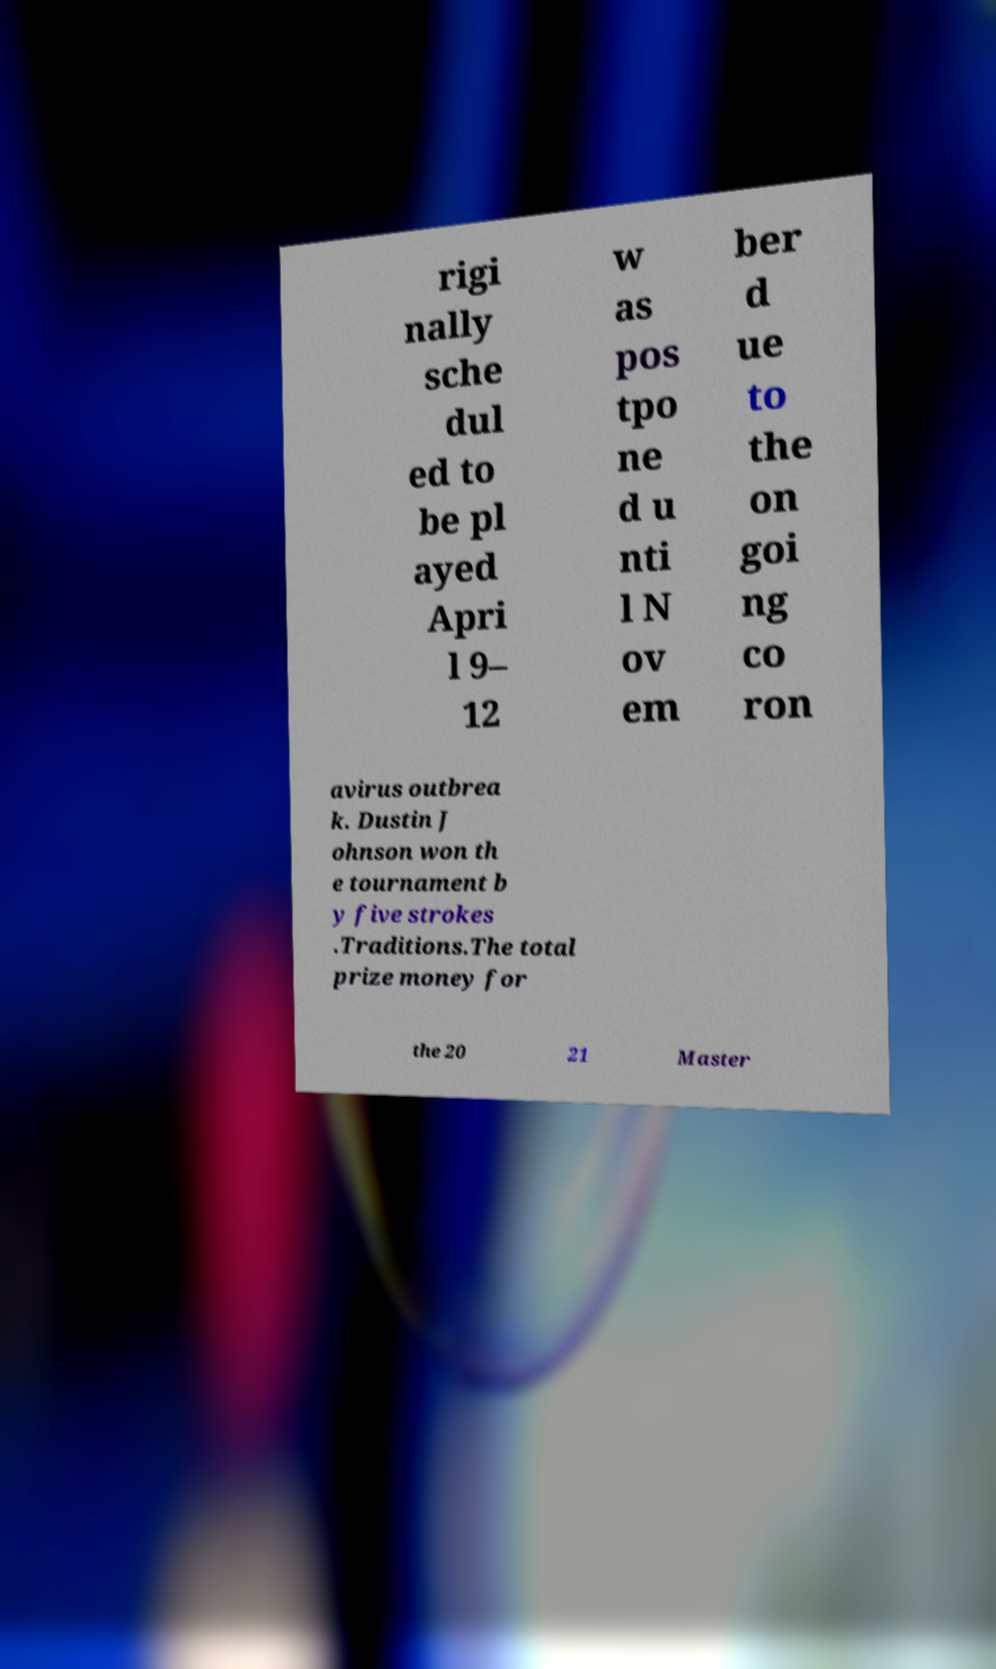There's text embedded in this image that I need extracted. Can you transcribe it verbatim? rigi nally sche dul ed to be pl ayed Apri l 9– 12 w as pos tpo ne d u nti l N ov em ber d ue to the on goi ng co ron avirus outbrea k. Dustin J ohnson won th e tournament b y five strokes .Traditions.The total prize money for the 20 21 Master 